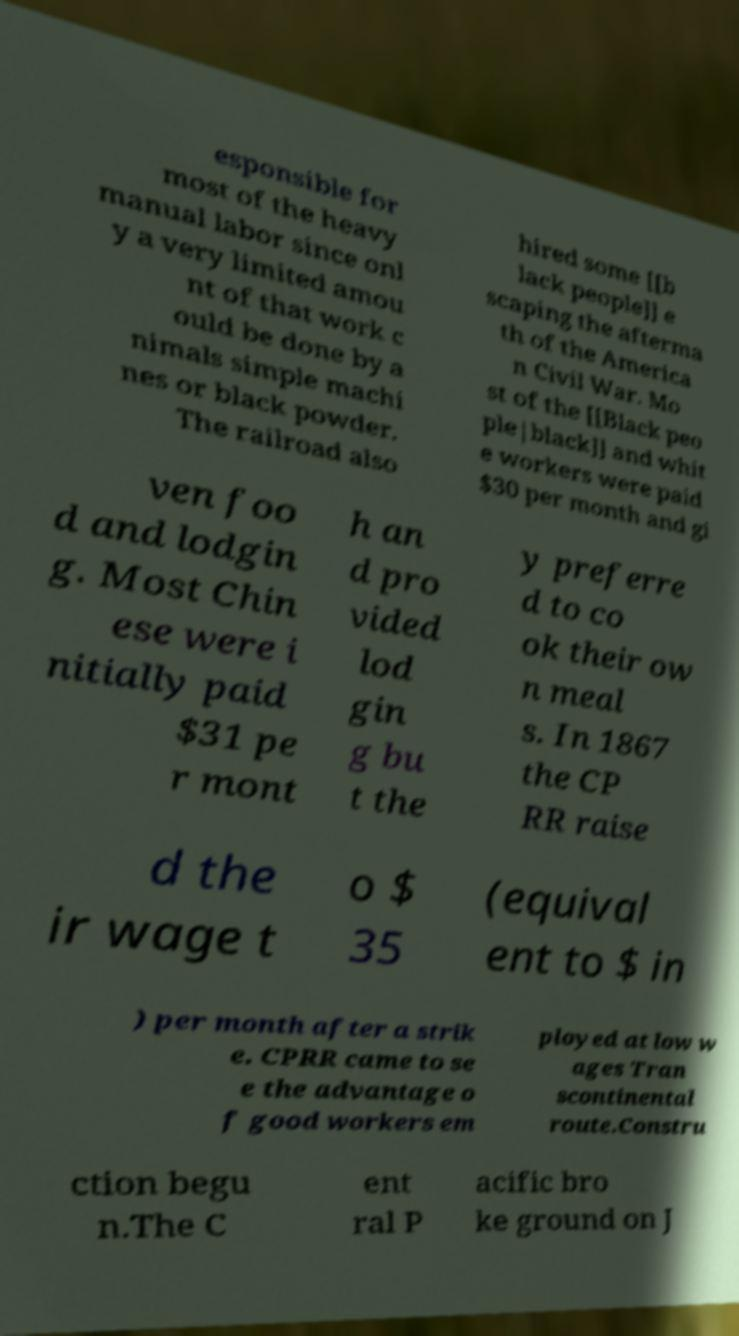Could you assist in decoding the text presented in this image and type it out clearly? esponsible for most of the heavy manual labor since onl y a very limited amou nt of that work c ould be done by a nimals simple machi nes or black powder. The railroad also hired some [[b lack people]] e scaping the afterma th of the America n Civil War. Mo st of the [[Black peo ple|black]] and whit e workers were paid $30 per month and gi ven foo d and lodgin g. Most Chin ese were i nitially paid $31 pe r mont h an d pro vided lod gin g bu t the y preferre d to co ok their ow n meal s. In 1867 the CP RR raise d the ir wage t o $ 35 (equival ent to $ in ) per month after a strik e. CPRR came to se e the advantage o f good workers em ployed at low w ages Tran scontinental route.Constru ction begu n.The C ent ral P acific bro ke ground on J 